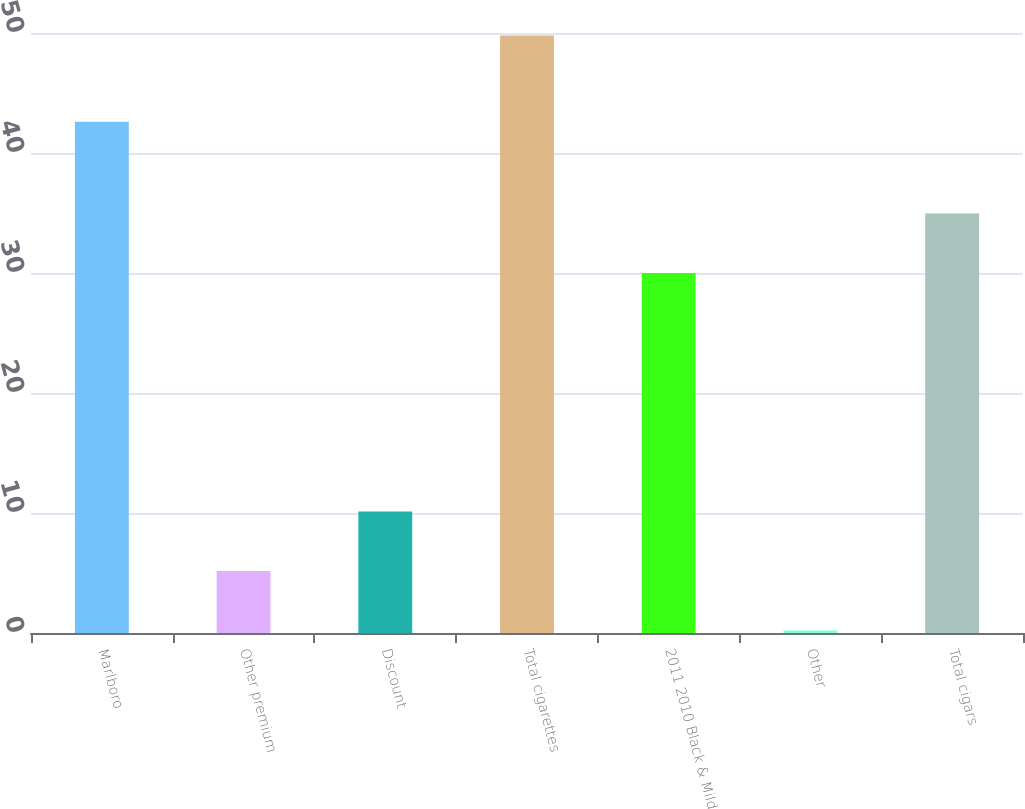Convert chart. <chart><loc_0><loc_0><loc_500><loc_500><bar_chart><fcel>Marlboro<fcel>Other premium<fcel>Discount<fcel>Total cigarettes<fcel>2011 2010 Black & Mild<fcel>Other<fcel>Total cigars<nl><fcel>42.6<fcel>5.16<fcel>10.12<fcel>49.8<fcel>30<fcel>0.2<fcel>34.96<nl></chart> 